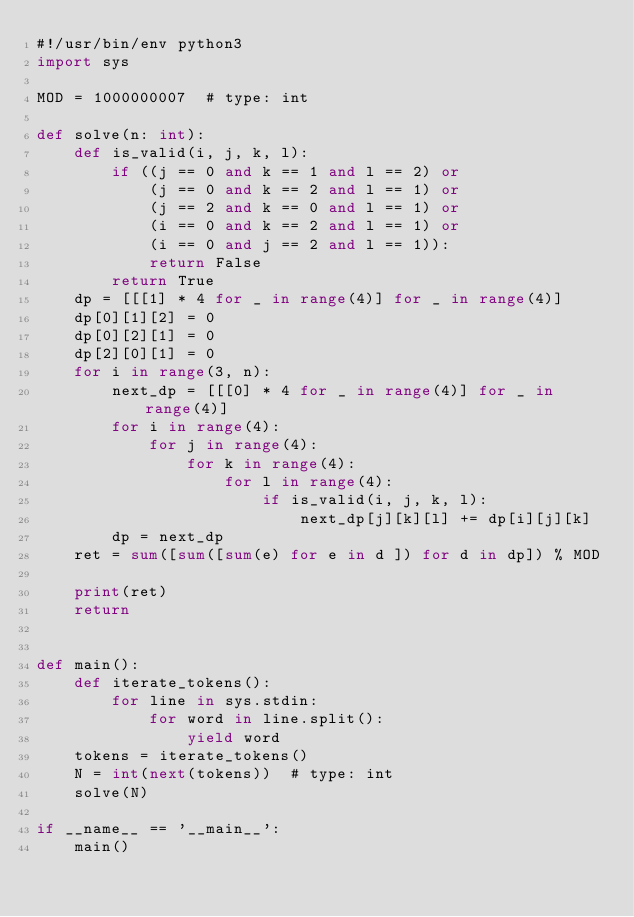Convert code to text. <code><loc_0><loc_0><loc_500><loc_500><_Python_>#!/usr/bin/env python3
import sys

MOD = 1000000007  # type: int

def solve(n: int):
    def is_valid(i, j, k, l):
        if ((j == 0 and k == 1 and l == 2) or
            (j == 0 and k == 2 and l == 1) or
            (j == 2 and k == 0 and l == 1) or
            (i == 0 and k == 2 and l == 1) or
            (i == 0 and j == 2 and l == 1)):
            return False
        return True
    dp = [[[1] * 4 for _ in range(4)] for _ in range(4)]
    dp[0][1][2] = 0
    dp[0][2][1] = 0
    dp[2][0][1] = 0
    for i in range(3, n):
        next_dp = [[[0] * 4 for _ in range(4)] for _ in range(4)]
        for i in range(4):
            for j in range(4):
                for k in range(4):
                    for l in range(4):
                        if is_valid(i, j, k, l):
                            next_dp[j][k][l] += dp[i][j][k]
        dp = next_dp
    ret = sum([sum([sum(e) for e in d ]) for d in dp]) % MOD

    print(ret)
    return


def main():
    def iterate_tokens():
        for line in sys.stdin:
            for word in line.split():
                yield word
    tokens = iterate_tokens()
    N = int(next(tokens))  # type: int
    solve(N)

if __name__ == '__main__':
    main()
</code> 